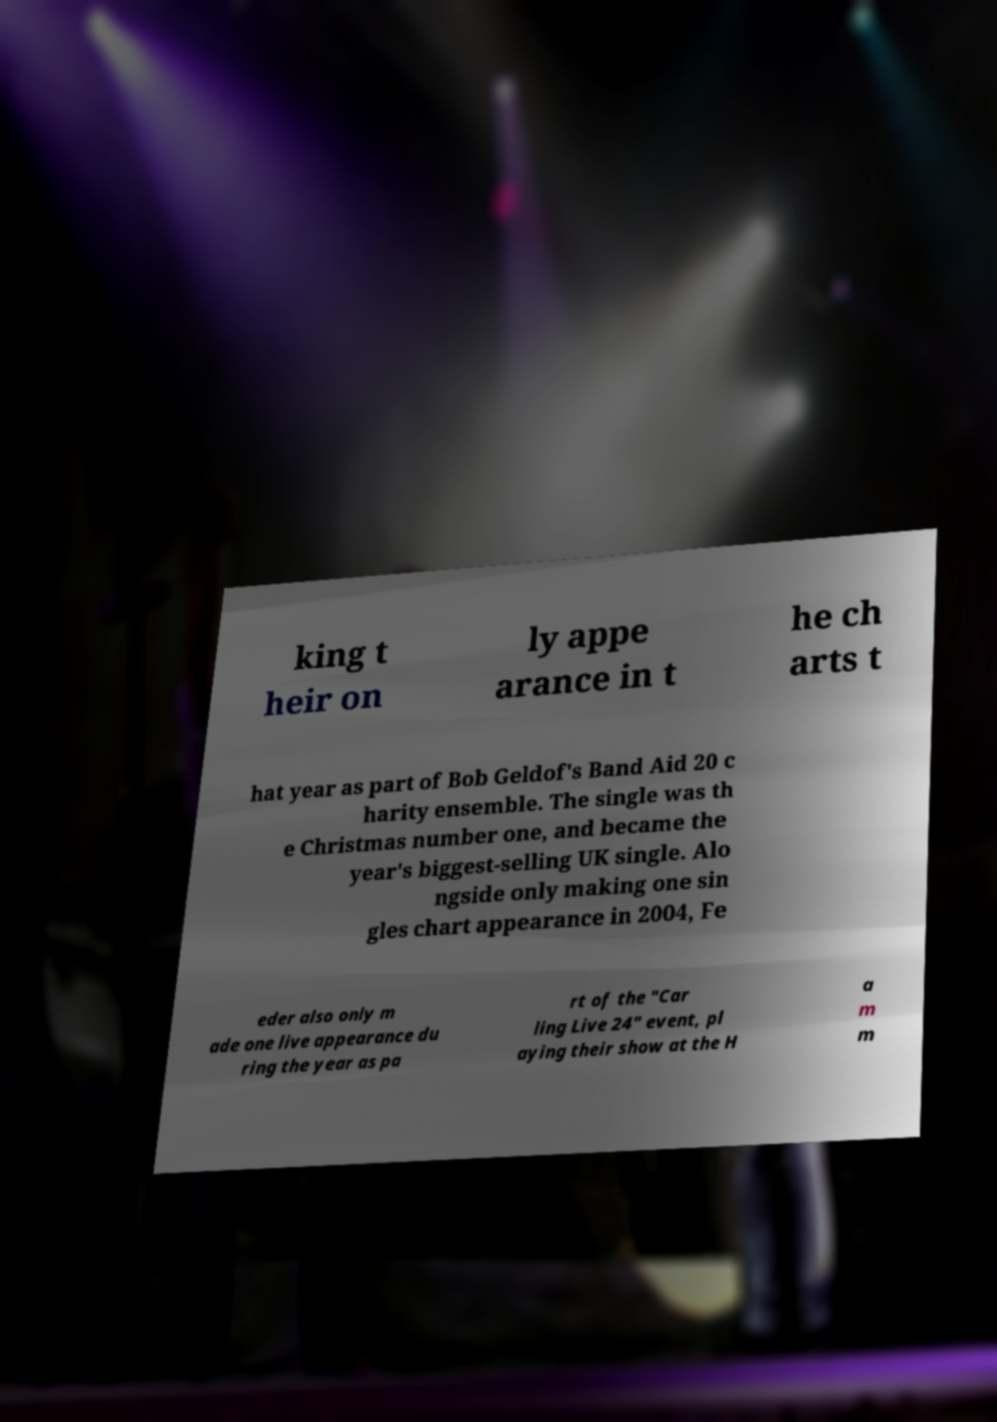Please read and relay the text visible in this image. What does it say? king t heir on ly appe arance in t he ch arts t hat year as part of Bob Geldof's Band Aid 20 c harity ensemble. The single was th e Christmas number one, and became the year's biggest-selling UK single. Alo ngside only making one sin gles chart appearance in 2004, Fe eder also only m ade one live appearance du ring the year as pa rt of the "Car ling Live 24" event, pl aying their show at the H a m m 